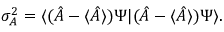<formula> <loc_0><loc_0><loc_500><loc_500>\sigma _ { A } ^ { 2 } = \langle ( { \hat { A } } - \langle { \hat { A } } \rangle ) \Psi | ( { \hat { A } } - \langle { \hat { A } } \rangle ) \Psi \rangle .</formula> 